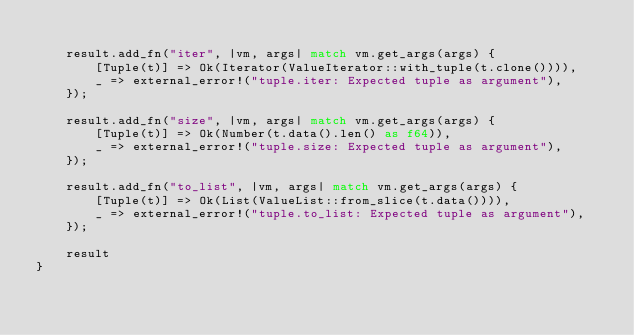Convert code to text. <code><loc_0><loc_0><loc_500><loc_500><_Rust_>
    result.add_fn("iter", |vm, args| match vm.get_args(args) {
        [Tuple(t)] => Ok(Iterator(ValueIterator::with_tuple(t.clone()))),
        _ => external_error!("tuple.iter: Expected tuple as argument"),
    });

    result.add_fn("size", |vm, args| match vm.get_args(args) {
        [Tuple(t)] => Ok(Number(t.data().len() as f64)),
        _ => external_error!("tuple.size: Expected tuple as argument"),
    });

    result.add_fn("to_list", |vm, args| match vm.get_args(args) {
        [Tuple(t)] => Ok(List(ValueList::from_slice(t.data()))),
        _ => external_error!("tuple.to_list: Expected tuple as argument"),
    });

    result
}
</code> 